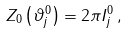Convert formula to latex. <formula><loc_0><loc_0><loc_500><loc_500>Z _ { 0 } \left ( \vartheta _ { j } ^ { 0 } \right ) = 2 \pi I _ { j } ^ { 0 } \, ,</formula> 